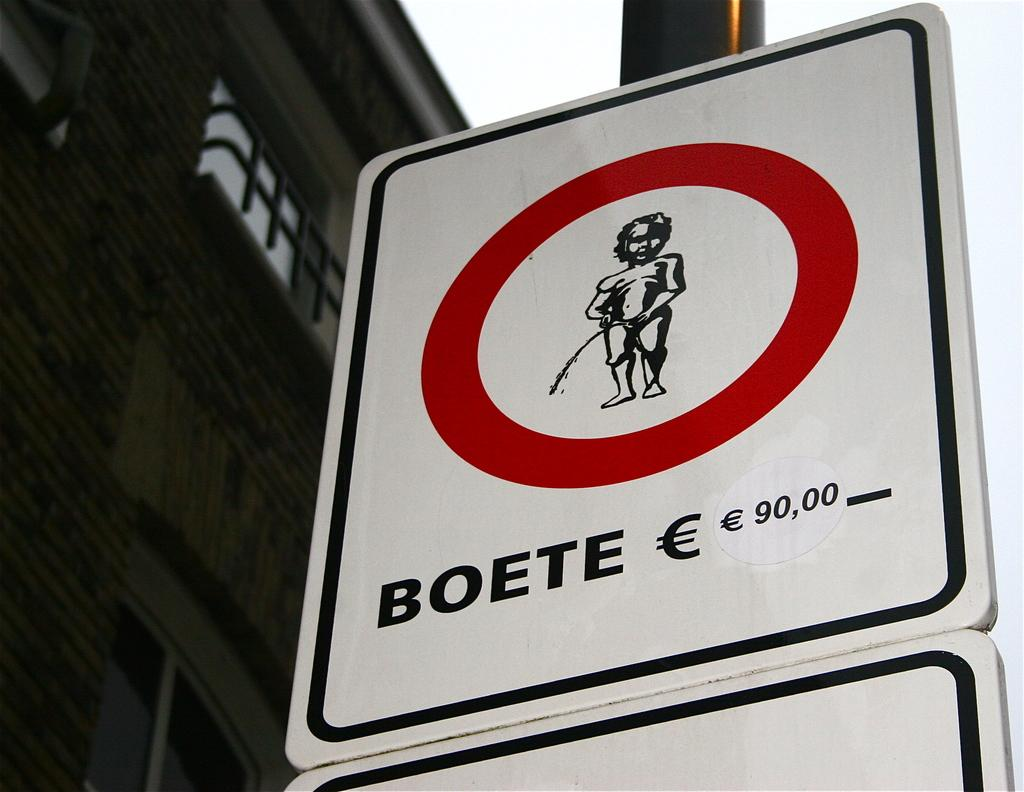<image>
Offer a succinct explanation of the picture presented. A sign depicting the fine for Boete being 90,00 euro. 